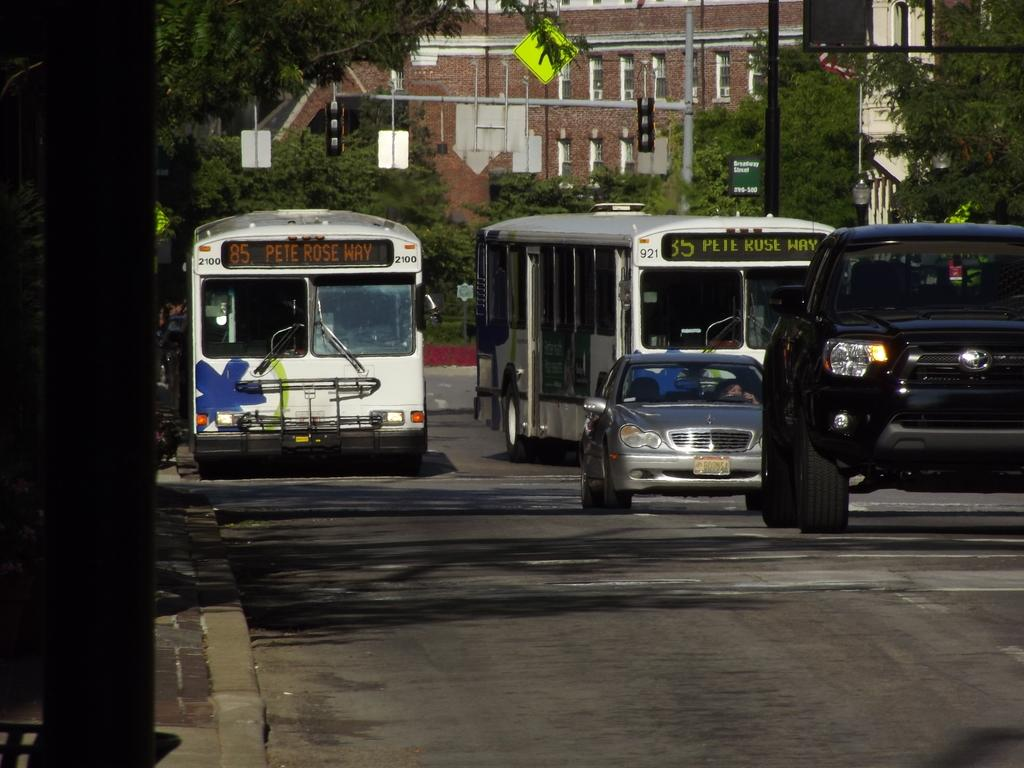What can be seen on the road in the image? There are vehicles on the road in the image. What is visible in the background of the image? Boards, signal lights, a flag, buildings, and trees are present in the background of the image. What type of stew is being served at the border in the image? There is no mention of a border or stew in the image; it features vehicles on the road and various elements in the background. How much money is visible in the image? There is no mention of money in the image. 